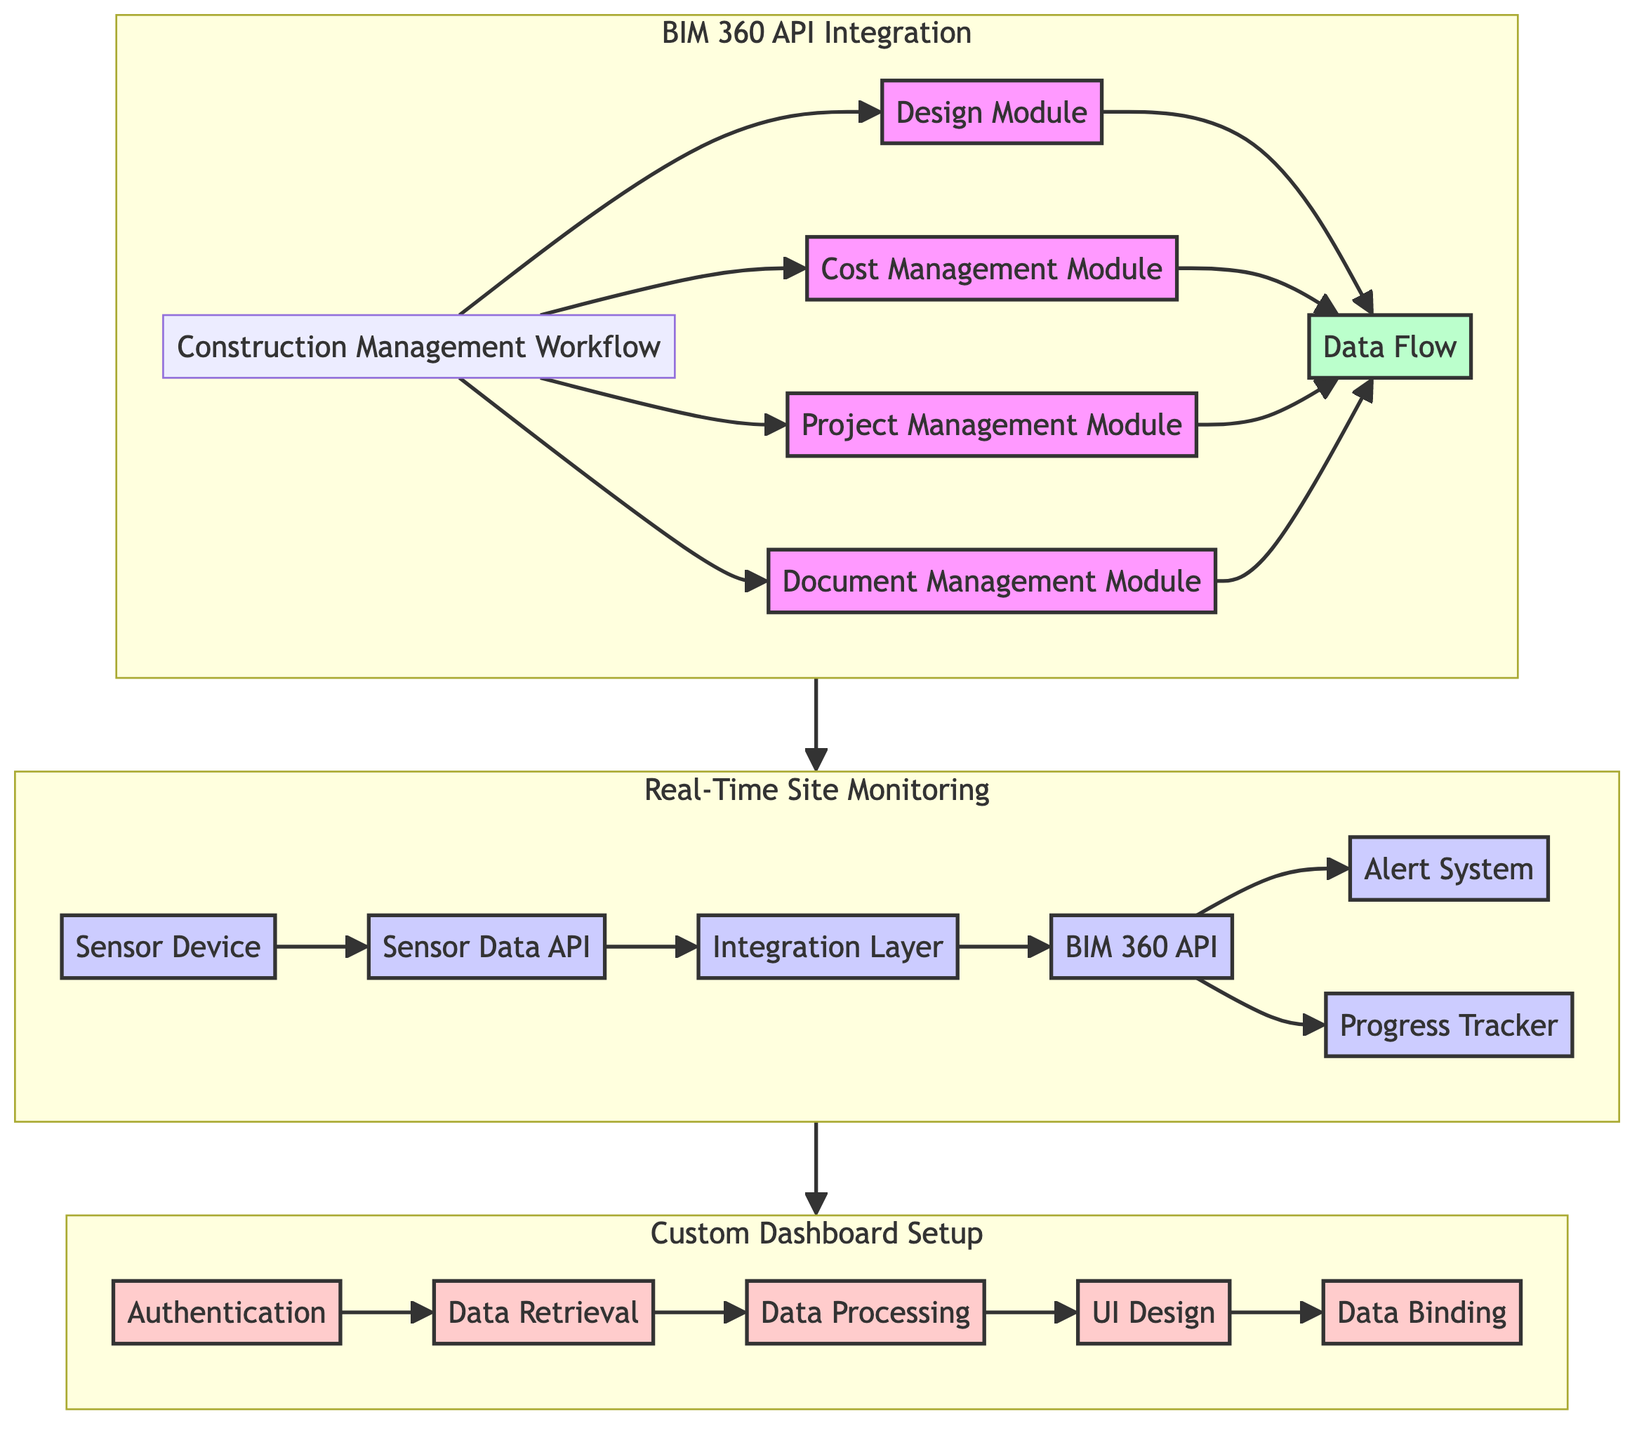What is the main workflow depicted in the BIM 360 API Integration subgraph? The main workflow is the "Construction Management Workflow," which is the starting point of the diagram and connects to multiple modules like Design, Cost Management, Project Management, and Document Management.
Answer: Construction Management Workflow How many modules are included in the BIM 360 API Integration section? There are four modules displayed in the BIM 360 API Integration section: Design Module, Cost Management Module, Project Management Module, and Document Management Module.
Answer: Four Which component is responsible for alert notifications in Real-Time Site Monitoring? The component responsible for alert notifications is the "Alert System," which receives data from the BIM 360 API and is depicted as one of the key elements in the Real-Time Site Monitoring subgraph.
Answer: Alert System What is the sequential first action in setting up the Custom Dashboard? The first action in setting up the Custom Dashboard is "Authentication," which is the starting point in the flow of actions depicted in the Custom Dashboard subgraph.
Answer: Authentication In the Real-Time Site Monitoring section, which component integrates the sensor data with the BIM 360 API? The component that integrates the sensor data with the BIM 360 API is the "Integration Layer," which shows the connection between sensor data and the BIM 360 API in the flow of the subgraph.
Answer: Integration Layer How does the Custom Dashboard connect to Real-Time Site Monitoring? The Custom Dashboard connects to Real-Time Site Monitoring through a data flow from the Real-Time Monitoring subgraph, indicating that data from real-time monitoring can be visualized in the custom dashboard setup.
Answer: Data flow Which module in the BIM 360 API Integration handles documentation? The module that handles documentation is the "Document Management Module," which is specifically named in the integration workflow nodes.
Answer: Document Management Module How many components are involved in the Real-Time Site Monitoring subgraph? There are five components involved in the Real-Time Site Monitoring subgraph: Sensor Device, Sensor Data API, Integration Layer, BIM 360 API, and Alert System, among others.
Answer: Five What is the last action in the setup process of the Custom Dashboard? The last action in the setup process is "Data Binding," which completes the flow of actions in designing the Custom Dashboard, culminating the previous steps.
Answer: Data Binding 